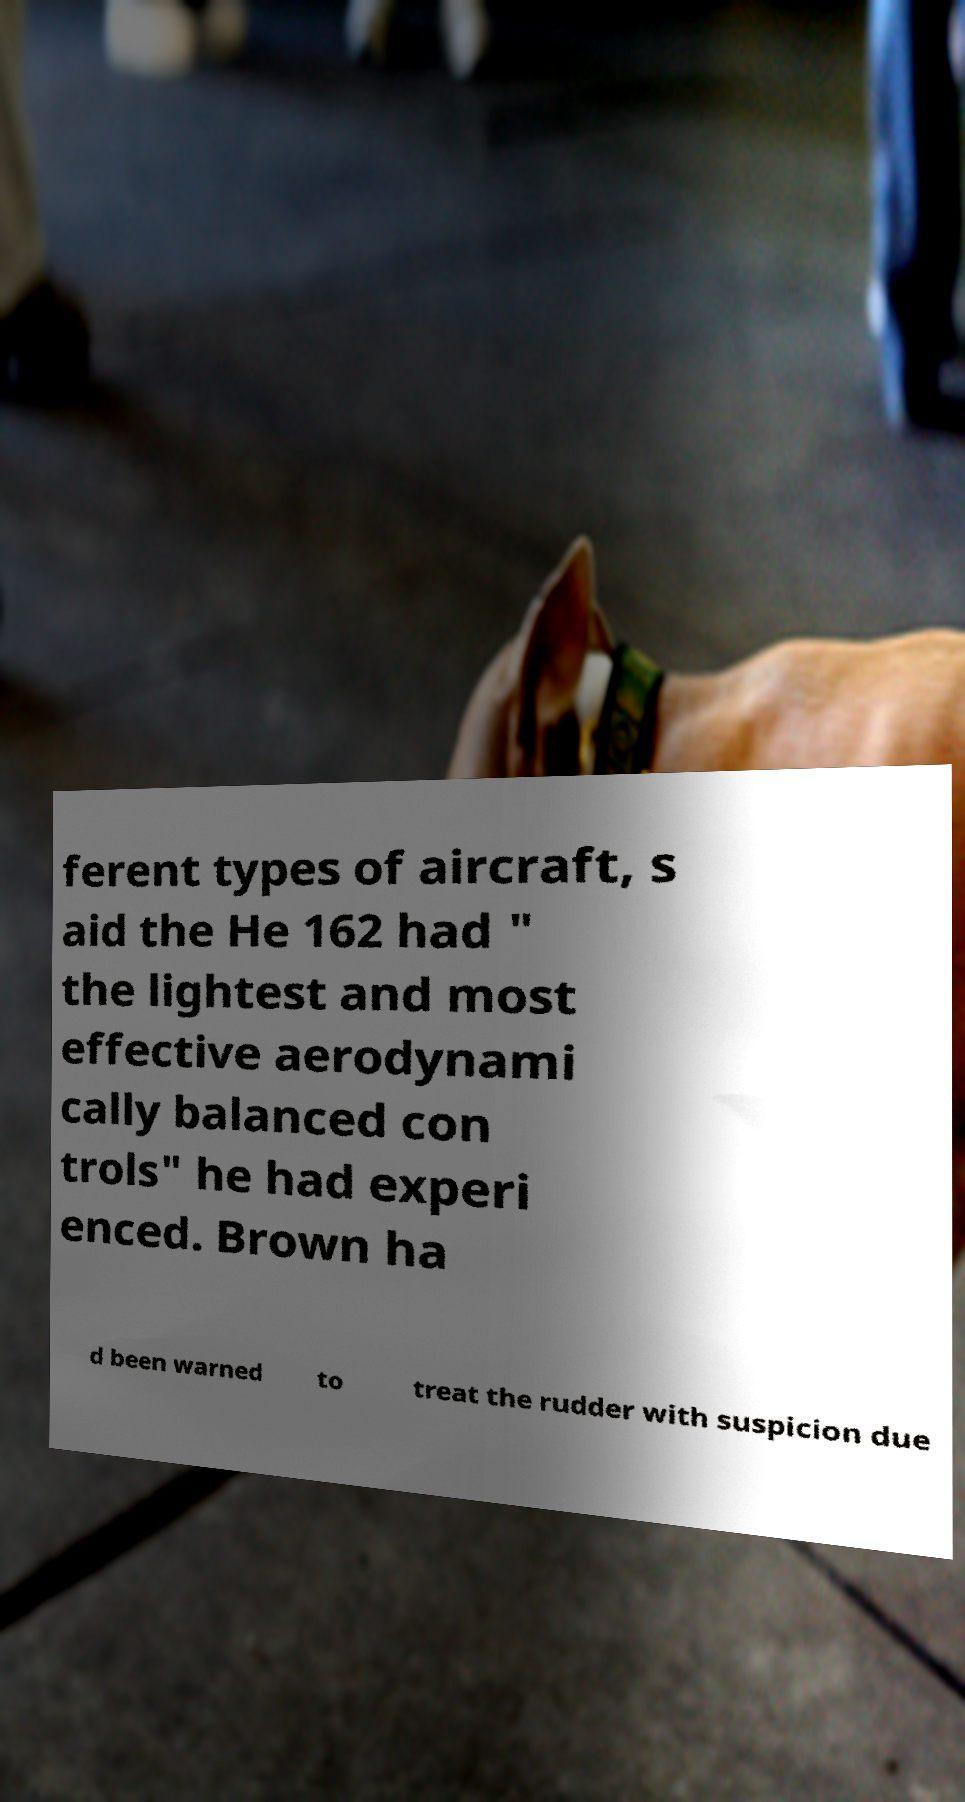Can you read and provide the text displayed in the image?This photo seems to have some interesting text. Can you extract and type it out for me? ferent types of aircraft, s aid the He 162 had " the lightest and most effective aerodynami cally balanced con trols" he had experi enced. Brown ha d been warned to treat the rudder with suspicion due 